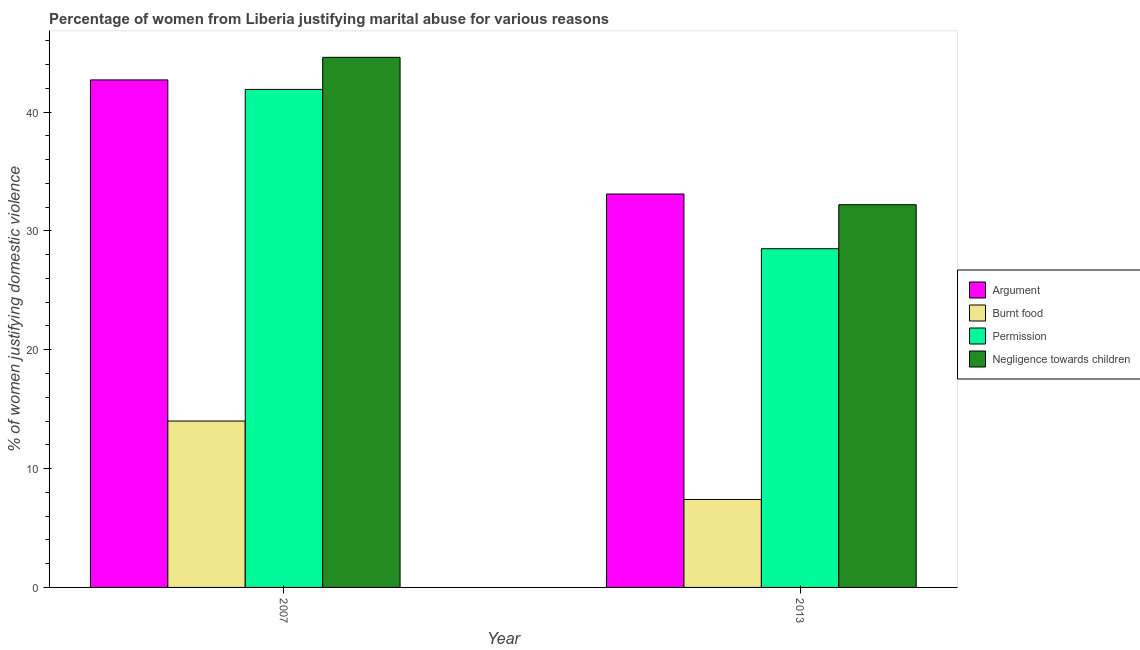How many groups of bars are there?
Provide a short and direct response. 2. Are the number of bars per tick equal to the number of legend labels?
Provide a succinct answer. Yes. Are the number of bars on each tick of the X-axis equal?
Offer a very short reply. Yes. How many bars are there on the 2nd tick from the right?
Offer a very short reply. 4. What is the label of the 2nd group of bars from the left?
Ensure brevity in your answer.  2013. In how many cases, is the number of bars for a given year not equal to the number of legend labels?
Your response must be concise. 0. What is the percentage of women justifying abuse in the case of an argument in 2007?
Your response must be concise. 42.7. Across all years, what is the minimum percentage of women justifying abuse for burning food?
Make the answer very short. 7.4. What is the total percentage of women justifying abuse for burning food in the graph?
Offer a very short reply. 21.4. What is the difference between the percentage of women justifying abuse for showing negligence towards children in 2007 and that in 2013?
Ensure brevity in your answer.  12.4. What is the difference between the percentage of women justifying abuse for showing negligence towards children in 2013 and the percentage of women justifying abuse in the case of an argument in 2007?
Ensure brevity in your answer.  -12.4. What is the average percentage of women justifying abuse in the case of an argument per year?
Offer a very short reply. 37.9. In the year 2013, what is the difference between the percentage of women justifying abuse for showing negligence towards children and percentage of women justifying abuse in the case of an argument?
Keep it short and to the point. 0. In how many years, is the percentage of women justifying abuse for showing negligence towards children greater than 28 %?
Your answer should be very brief. 2. What is the ratio of the percentage of women justifying abuse for showing negligence towards children in 2007 to that in 2013?
Provide a succinct answer. 1.39. What does the 1st bar from the left in 2013 represents?
Make the answer very short. Argument. What does the 2nd bar from the right in 2007 represents?
Offer a very short reply. Permission. Is it the case that in every year, the sum of the percentage of women justifying abuse in the case of an argument and percentage of women justifying abuse for burning food is greater than the percentage of women justifying abuse for going without permission?
Provide a succinct answer. Yes. How many bars are there?
Your answer should be very brief. 8. Are all the bars in the graph horizontal?
Offer a terse response. No. How many years are there in the graph?
Offer a terse response. 2. Are the values on the major ticks of Y-axis written in scientific E-notation?
Ensure brevity in your answer.  No. What is the title of the graph?
Provide a succinct answer. Percentage of women from Liberia justifying marital abuse for various reasons. What is the label or title of the X-axis?
Provide a succinct answer. Year. What is the label or title of the Y-axis?
Provide a succinct answer. % of women justifying domestic violence. What is the % of women justifying domestic violence in Argument in 2007?
Make the answer very short. 42.7. What is the % of women justifying domestic violence of Permission in 2007?
Make the answer very short. 41.9. What is the % of women justifying domestic violence of Negligence towards children in 2007?
Your answer should be compact. 44.6. What is the % of women justifying domestic violence of Argument in 2013?
Ensure brevity in your answer.  33.1. What is the % of women justifying domestic violence in Permission in 2013?
Ensure brevity in your answer.  28.5. What is the % of women justifying domestic violence in Negligence towards children in 2013?
Ensure brevity in your answer.  32.2. Across all years, what is the maximum % of women justifying domestic violence of Argument?
Provide a short and direct response. 42.7. Across all years, what is the maximum % of women justifying domestic violence in Burnt food?
Your answer should be compact. 14. Across all years, what is the maximum % of women justifying domestic violence of Permission?
Your response must be concise. 41.9. Across all years, what is the maximum % of women justifying domestic violence in Negligence towards children?
Your answer should be very brief. 44.6. Across all years, what is the minimum % of women justifying domestic violence in Argument?
Give a very brief answer. 33.1. Across all years, what is the minimum % of women justifying domestic violence of Negligence towards children?
Your answer should be very brief. 32.2. What is the total % of women justifying domestic violence in Argument in the graph?
Provide a succinct answer. 75.8. What is the total % of women justifying domestic violence of Burnt food in the graph?
Ensure brevity in your answer.  21.4. What is the total % of women justifying domestic violence of Permission in the graph?
Your answer should be very brief. 70.4. What is the total % of women justifying domestic violence in Negligence towards children in the graph?
Keep it short and to the point. 76.8. What is the difference between the % of women justifying domestic violence in Argument in 2007 and that in 2013?
Give a very brief answer. 9.6. What is the difference between the % of women justifying domestic violence in Burnt food in 2007 and that in 2013?
Your answer should be compact. 6.6. What is the difference between the % of women justifying domestic violence of Permission in 2007 and that in 2013?
Your response must be concise. 13.4. What is the difference between the % of women justifying domestic violence in Argument in 2007 and the % of women justifying domestic violence in Burnt food in 2013?
Offer a terse response. 35.3. What is the difference between the % of women justifying domestic violence of Burnt food in 2007 and the % of women justifying domestic violence of Negligence towards children in 2013?
Give a very brief answer. -18.2. What is the average % of women justifying domestic violence in Argument per year?
Make the answer very short. 37.9. What is the average % of women justifying domestic violence in Permission per year?
Provide a succinct answer. 35.2. What is the average % of women justifying domestic violence of Negligence towards children per year?
Offer a terse response. 38.4. In the year 2007, what is the difference between the % of women justifying domestic violence in Argument and % of women justifying domestic violence in Burnt food?
Provide a succinct answer. 28.7. In the year 2007, what is the difference between the % of women justifying domestic violence of Argument and % of women justifying domestic violence of Permission?
Make the answer very short. 0.8. In the year 2007, what is the difference between the % of women justifying domestic violence of Burnt food and % of women justifying domestic violence of Permission?
Make the answer very short. -27.9. In the year 2007, what is the difference between the % of women justifying domestic violence of Burnt food and % of women justifying domestic violence of Negligence towards children?
Provide a succinct answer. -30.6. In the year 2013, what is the difference between the % of women justifying domestic violence in Argument and % of women justifying domestic violence in Burnt food?
Offer a very short reply. 25.7. In the year 2013, what is the difference between the % of women justifying domestic violence of Argument and % of women justifying domestic violence of Negligence towards children?
Offer a very short reply. 0.9. In the year 2013, what is the difference between the % of women justifying domestic violence in Burnt food and % of women justifying domestic violence in Permission?
Offer a very short reply. -21.1. In the year 2013, what is the difference between the % of women justifying domestic violence of Burnt food and % of women justifying domestic violence of Negligence towards children?
Ensure brevity in your answer.  -24.8. In the year 2013, what is the difference between the % of women justifying domestic violence in Permission and % of women justifying domestic violence in Negligence towards children?
Your answer should be very brief. -3.7. What is the ratio of the % of women justifying domestic violence in Argument in 2007 to that in 2013?
Your response must be concise. 1.29. What is the ratio of the % of women justifying domestic violence in Burnt food in 2007 to that in 2013?
Offer a very short reply. 1.89. What is the ratio of the % of women justifying domestic violence in Permission in 2007 to that in 2013?
Offer a terse response. 1.47. What is the ratio of the % of women justifying domestic violence of Negligence towards children in 2007 to that in 2013?
Provide a succinct answer. 1.39. What is the difference between the highest and the second highest % of women justifying domestic violence of Argument?
Your answer should be very brief. 9.6. What is the difference between the highest and the second highest % of women justifying domestic violence in Burnt food?
Ensure brevity in your answer.  6.6. What is the difference between the highest and the second highest % of women justifying domestic violence of Permission?
Provide a short and direct response. 13.4. What is the difference between the highest and the lowest % of women justifying domestic violence of Argument?
Offer a very short reply. 9.6. What is the difference between the highest and the lowest % of women justifying domestic violence of Burnt food?
Offer a very short reply. 6.6. What is the difference between the highest and the lowest % of women justifying domestic violence of Permission?
Offer a very short reply. 13.4. 